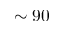Convert formula to latex. <formula><loc_0><loc_0><loc_500><loc_500>\sim 9 0</formula> 